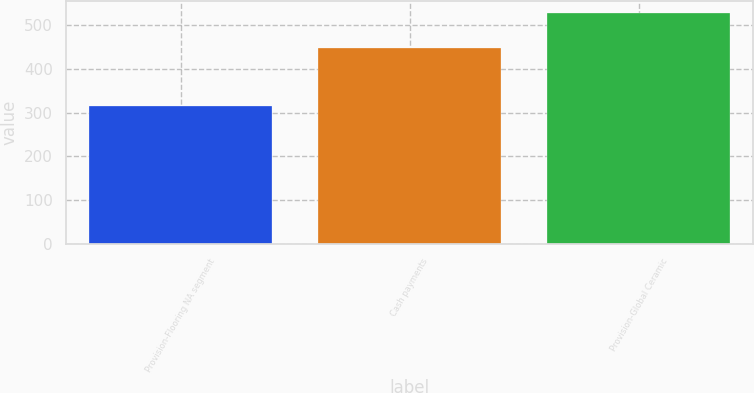Convert chart. <chart><loc_0><loc_0><loc_500><loc_500><bar_chart><fcel>Provision-Flooring NA segment<fcel>Cash payments<fcel>Provision-Global Ceramic<nl><fcel>316<fcel>449<fcel>528<nl></chart> 